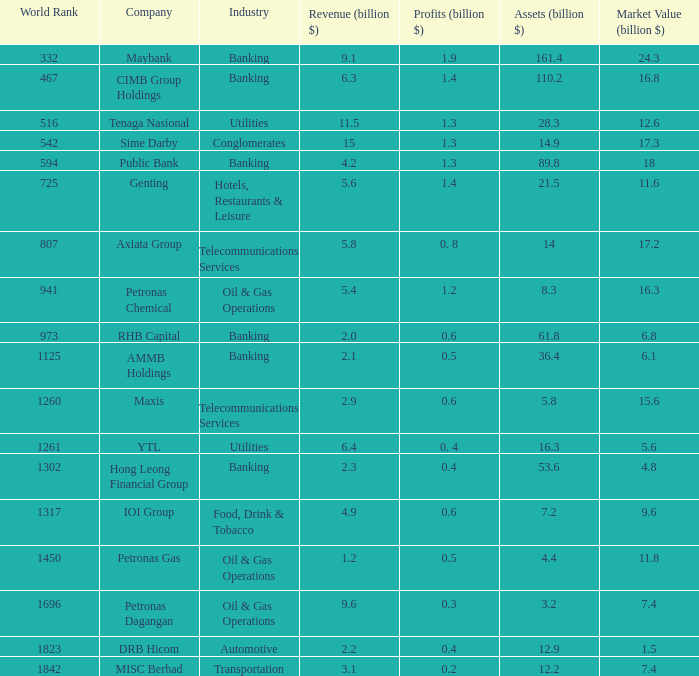Specify the gains for market value of 1 0.5. 